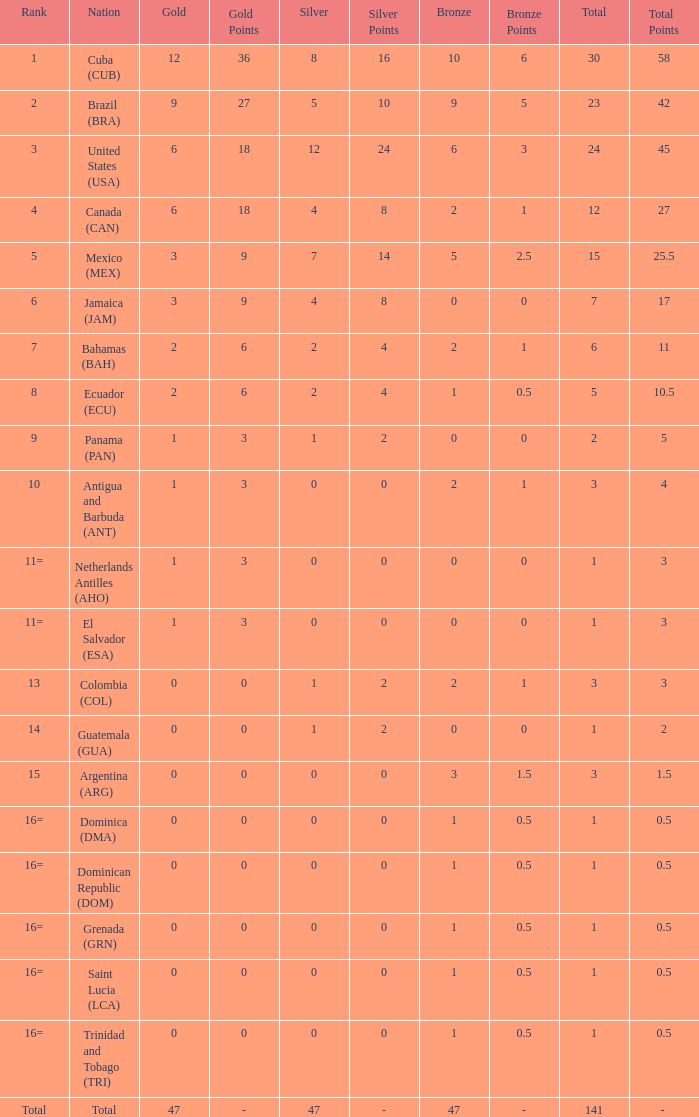How many bronzes have a Nation of jamaica (jam), and a Total smaller than 7? 0.0. Would you be able to parse every entry in this table? {'header': ['Rank', 'Nation', 'Gold', 'Gold Points', 'Silver', 'Silver Points', 'Bronze', 'Bronze Points', 'Total', 'Total Points'], 'rows': [['1', 'Cuba (CUB)', '12', '36', '8', '16', '10', '6', '30', '58'], ['2', 'Brazil (BRA)', '9', '27', '5', '10', '9', '5', '23', '42'], ['3', 'United States (USA)', '6', '18', '12', '24', '6', '3', '24', '45'], ['4', 'Canada (CAN)', '6', '18', '4', '8', '2', '1', '12', '27'], ['5', 'Mexico (MEX)', '3', '9', '7', '14', '5', '2.5', '15', '25.5'], ['6', 'Jamaica (JAM)', '3', '9', '4', '8', '0', '0', '7', '17'], ['7', 'Bahamas (BAH)', '2', '6', '2', '4', '2', '1', '6', '11'], ['8', 'Ecuador (ECU)', '2', '6', '2', '4', '1', '0.5', '5', '10.5'], ['9', 'Panama (PAN)', '1', '3', '1', '2', '0', '0', '2', '5'], ['10', 'Antigua and Barbuda (ANT)', '1', '3', '0', '0', '2', '1', '3', '4'], ['11=', 'Netherlands Antilles (AHO)', '1', '3', '0', '0', '0', '0', '1', '3'], ['11=', 'El Salvador (ESA)', '1', '3', '0', '0', '0', '0', '1', '3'], ['13', 'Colombia (COL)', '0', '0', '1', '2', '2', '1', '3', '3'], ['14', 'Guatemala (GUA)', '0', '0', '1', '2', '0', '0', '1', '2'], ['15', 'Argentina (ARG)', '0', '0', '0', '0', '3', '1.5', '3', '1.5'], ['16=', 'Dominica (DMA)', '0', '0', '0', '0', '1', '0.5', '1', '0.5'], ['16=', 'Dominican Republic (DOM)', '0', '0', '0', '0', '1', '0.5', '1', '0.5'], ['16=', 'Grenada (GRN)', '0', '0', '0', '0', '1', '0.5', '1', '0.5'], ['16=', 'Saint Lucia (LCA)', '0', '0', '0', '0', '1', '0.5', '1', '0.5'], ['16=', 'Trinidad and Tobago (TRI)', '0', '0', '0', '0', '1', '0.5', '1', '0.5'], ['Total', 'Total', '47', '-', '47', '-', '47', '-', '141', '- ']]} 